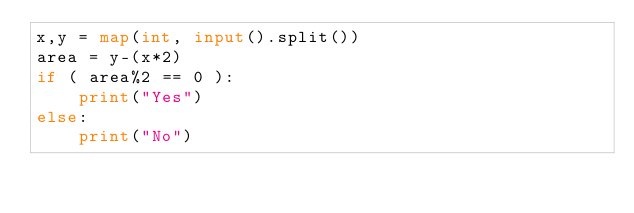<code> <loc_0><loc_0><loc_500><loc_500><_Python_>x,y = map(int, input().split())
area = y-(x*2)
if ( area%2 == 0 ):
    print("Yes")
else:
    print("No")</code> 